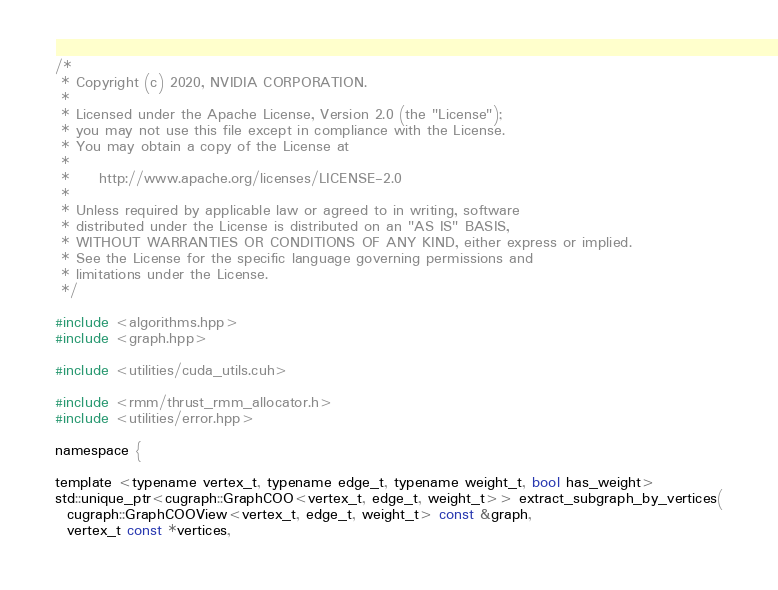Convert code to text. <code><loc_0><loc_0><loc_500><loc_500><_Cuda_>/*
 * Copyright (c) 2020, NVIDIA CORPORATION.
 *
 * Licensed under the Apache License, Version 2.0 (the "License");
 * you may not use this file except in compliance with the License.
 * You may obtain a copy of the License at
 *
 *     http://www.apache.org/licenses/LICENSE-2.0
 *
 * Unless required by applicable law or agreed to in writing, software
 * distributed under the License is distributed on an "AS IS" BASIS,
 * WITHOUT WARRANTIES OR CONDITIONS OF ANY KIND, either express or implied.
 * See the License for the specific language governing permissions and
 * limitations under the License.
 */

#include <algorithms.hpp>
#include <graph.hpp>

#include <utilities/cuda_utils.cuh>

#include <rmm/thrust_rmm_allocator.h>
#include <utilities/error.hpp>

namespace {

template <typename vertex_t, typename edge_t, typename weight_t, bool has_weight>
std::unique_ptr<cugraph::GraphCOO<vertex_t, edge_t, weight_t>> extract_subgraph_by_vertices(
  cugraph::GraphCOOView<vertex_t, edge_t, weight_t> const &graph,
  vertex_t const *vertices,</code> 